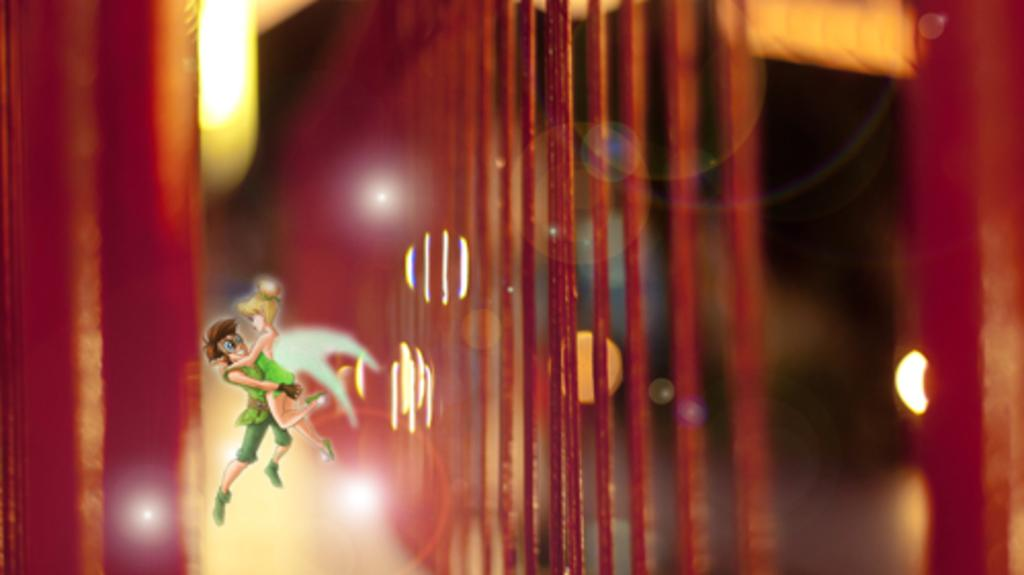What is happening in the animated image in the picture? There is an animated image of a man holding a girl in his hands. Can you describe the background of the image? The background of the image is not clear, but red color threads and lights are visible. How much respect does the man show towards the girl in the image? The image does not convey any information about the level of respect the man shows towards the girl. What type of mask is the girl wearing in the image? There is no mask present in the image; it features an animated image of a man holding a girl in his hands. 